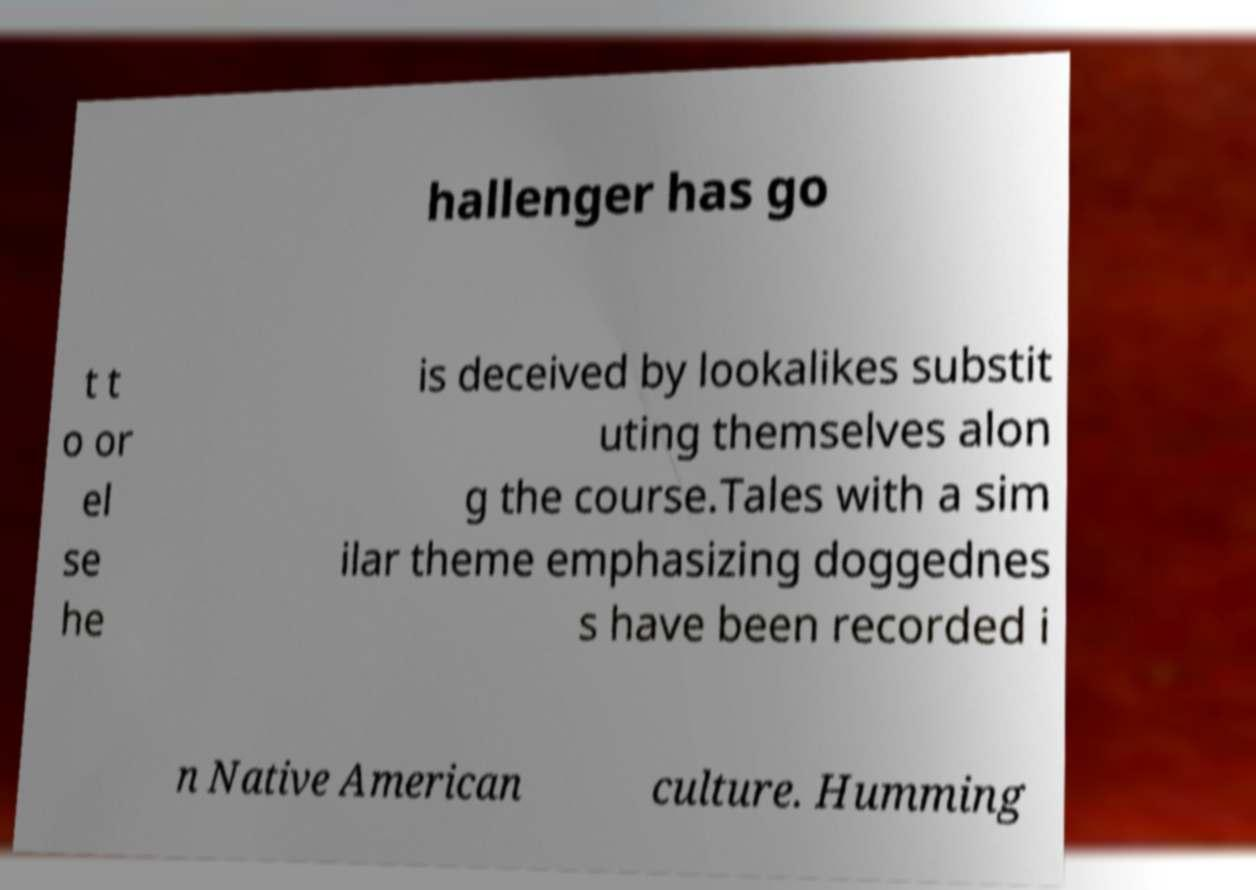Can you accurately transcribe the text from the provided image for me? hallenger has go t t o or el se he is deceived by lookalikes substit uting themselves alon g the course.Tales with a sim ilar theme emphasizing doggednes s have been recorded i n Native American culture. Humming 